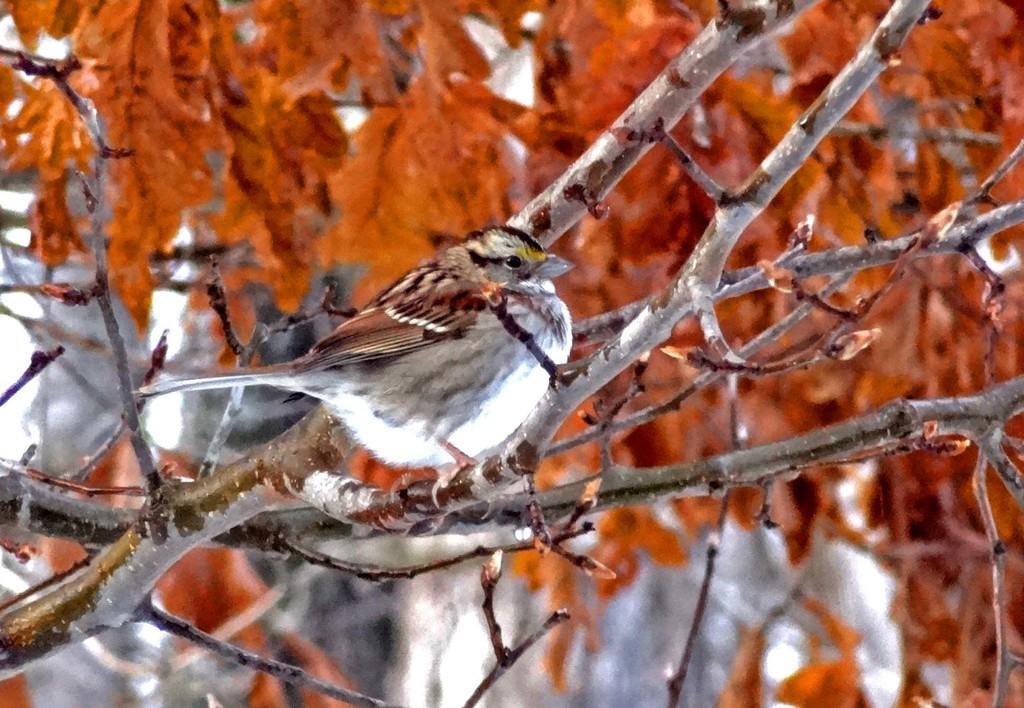Describe this image in one or two sentences. In this image I can see a bird which is in white and cream color, and I can see orange and white color background. 